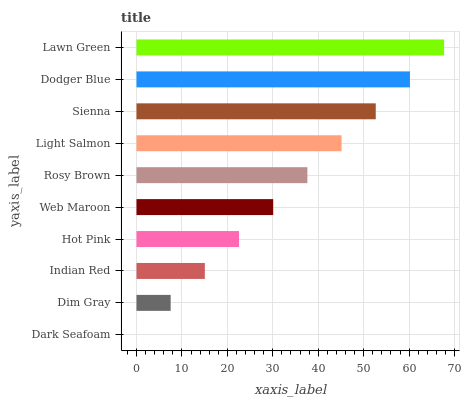Is Dark Seafoam the minimum?
Answer yes or no. Yes. Is Lawn Green the maximum?
Answer yes or no. Yes. Is Dim Gray the minimum?
Answer yes or no. No. Is Dim Gray the maximum?
Answer yes or no. No. Is Dim Gray greater than Dark Seafoam?
Answer yes or no. Yes. Is Dark Seafoam less than Dim Gray?
Answer yes or no. Yes. Is Dark Seafoam greater than Dim Gray?
Answer yes or no. No. Is Dim Gray less than Dark Seafoam?
Answer yes or no. No. Is Rosy Brown the high median?
Answer yes or no. Yes. Is Web Maroon the low median?
Answer yes or no. Yes. Is Sienna the high median?
Answer yes or no. No. Is Dodger Blue the low median?
Answer yes or no. No. 